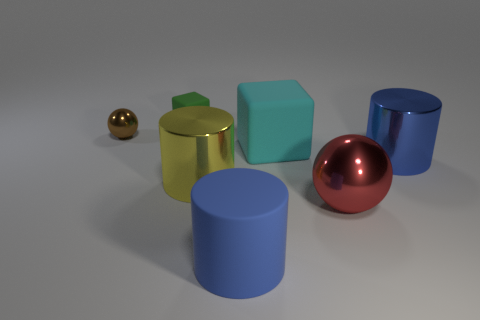There is a brown shiny thing; is it the same shape as the large red object that is in front of the cyan block?
Keep it short and to the point. Yes. The blue object that is to the left of the blue cylinder right of the matte thing that is in front of the large cyan rubber object is what shape?
Ensure brevity in your answer.  Cylinder. What number of other things are made of the same material as the big yellow cylinder?
Your answer should be very brief. 3. How many things are small objects on the right side of the brown shiny thing or big yellow cylinders?
Make the answer very short. 2. What shape is the blue matte thing in front of the thing that is left of the tiny block?
Provide a succinct answer. Cylinder. Do the large blue object behind the large red shiny sphere and the yellow thing have the same shape?
Ensure brevity in your answer.  Yes. What color is the shiny cylinder to the left of the red metal thing?
Your answer should be compact. Yellow. How many spheres are tiny yellow objects or big metal things?
Ensure brevity in your answer.  1. What is the size of the shiny sphere that is on the left side of the ball in front of the small ball?
Your answer should be very brief. Small. Do the large rubber cylinder and the large metallic cylinder behind the yellow metal thing have the same color?
Provide a short and direct response. Yes. 